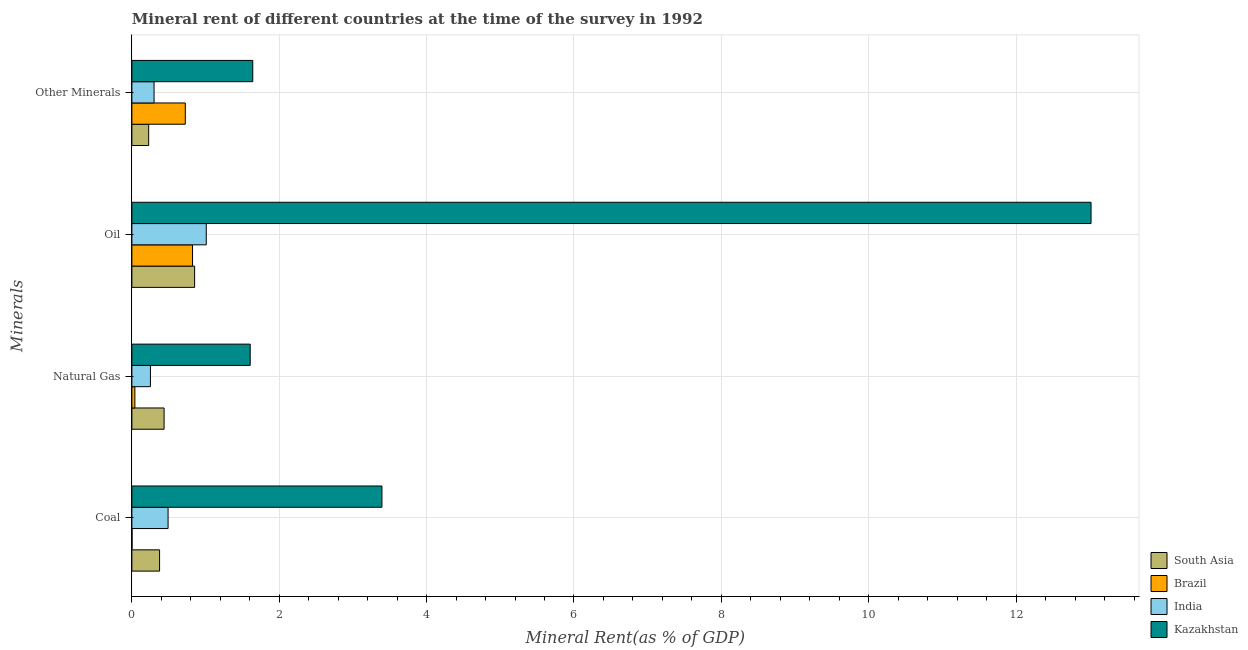How many groups of bars are there?
Provide a succinct answer. 4. Are the number of bars on each tick of the Y-axis equal?
Provide a short and direct response. Yes. How many bars are there on the 1st tick from the top?
Offer a terse response. 4. What is the label of the 1st group of bars from the top?
Ensure brevity in your answer.  Other Minerals. What is the  rent of other minerals in South Asia?
Your answer should be compact. 0.23. Across all countries, what is the maximum coal rent?
Provide a short and direct response. 3.39. Across all countries, what is the minimum coal rent?
Give a very brief answer. 0. In which country was the natural gas rent maximum?
Provide a short and direct response. Kazakhstan. In which country was the  rent of other minerals minimum?
Keep it short and to the point. South Asia. What is the total  rent of other minerals in the graph?
Your answer should be very brief. 2.89. What is the difference between the coal rent in Kazakhstan and that in South Asia?
Your response must be concise. 3.02. What is the difference between the coal rent in Brazil and the oil rent in Kazakhstan?
Your answer should be very brief. -13.01. What is the average oil rent per country?
Ensure brevity in your answer.  3.93. What is the difference between the oil rent and coal rent in Brazil?
Give a very brief answer. 0.82. What is the ratio of the oil rent in South Asia to that in Brazil?
Offer a terse response. 1.03. Is the difference between the natural gas rent in Kazakhstan and India greater than the difference between the  rent of other minerals in Kazakhstan and India?
Ensure brevity in your answer.  Yes. What is the difference between the highest and the second highest  rent of other minerals?
Ensure brevity in your answer.  0.92. What is the difference between the highest and the lowest natural gas rent?
Your response must be concise. 1.57. In how many countries, is the  rent of other minerals greater than the average  rent of other minerals taken over all countries?
Provide a succinct answer. 2. Is it the case that in every country, the sum of the coal rent and natural gas rent is greater than the oil rent?
Your answer should be very brief. No. How many bars are there?
Provide a short and direct response. 16. Are all the bars in the graph horizontal?
Offer a terse response. Yes. How many countries are there in the graph?
Provide a short and direct response. 4. Does the graph contain grids?
Ensure brevity in your answer.  Yes. Where does the legend appear in the graph?
Give a very brief answer. Bottom right. What is the title of the graph?
Your answer should be compact. Mineral rent of different countries at the time of the survey in 1992. What is the label or title of the X-axis?
Your answer should be very brief. Mineral Rent(as % of GDP). What is the label or title of the Y-axis?
Give a very brief answer. Minerals. What is the Mineral Rent(as % of GDP) of South Asia in Coal?
Your answer should be very brief. 0.38. What is the Mineral Rent(as % of GDP) in Brazil in Coal?
Ensure brevity in your answer.  0. What is the Mineral Rent(as % of GDP) in India in Coal?
Your answer should be compact. 0.49. What is the Mineral Rent(as % of GDP) of Kazakhstan in Coal?
Give a very brief answer. 3.39. What is the Mineral Rent(as % of GDP) in South Asia in Natural Gas?
Make the answer very short. 0.44. What is the Mineral Rent(as % of GDP) of Brazil in Natural Gas?
Give a very brief answer. 0.04. What is the Mineral Rent(as % of GDP) in India in Natural Gas?
Offer a terse response. 0.25. What is the Mineral Rent(as % of GDP) in Kazakhstan in Natural Gas?
Offer a very short reply. 1.61. What is the Mineral Rent(as % of GDP) in South Asia in Oil?
Offer a terse response. 0.85. What is the Mineral Rent(as % of GDP) of Brazil in Oil?
Give a very brief answer. 0.82. What is the Mineral Rent(as % of GDP) in India in Oil?
Provide a succinct answer. 1.01. What is the Mineral Rent(as % of GDP) of Kazakhstan in Oil?
Provide a succinct answer. 13.02. What is the Mineral Rent(as % of GDP) of South Asia in Other Minerals?
Your answer should be very brief. 0.23. What is the Mineral Rent(as % of GDP) of Brazil in Other Minerals?
Keep it short and to the point. 0.73. What is the Mineral Rent(as % of GDP) of India in Other Minerals?
Ensure brevity in your answer.  0.3. What is the Mineral Rent(as % of GDP) in Kazakhstan in Other Minerals?
Give a very brief answer. 1.64. Across all Minerals, what is the maximum Mineral Rent(as % of GDP) of South Asia?
Give a very brief answer. 0.85. Across all Minerals, what is the maximum Mineral Rent(as % of GDP) of Brazil?
Your answer should be compact. 0.82. Across all Minerals, what is the maximum Mineral Rent(as % of GDP) in India?
Your answer should be compact. 1.01. Across all Minerals, what is the maximum Mineral Rent(as % of GDP) in Kazakhstan?
Provide a succinct answer. 13.02. Across all Minerals, what is the minimum Mineral Rent(as % of GDP) of South Asia?
Provide a short and direct response. 0.23. Across all Minerals, what is the minimum Mineral Rent(as % of GDP) of Brazil?
Give a very brief answer. 0. Across all Minerals, what is the minimum Mineral Rent(as % of GDP) of India?
Your answer should be very brief. 0.25. Across all Minerals, what is the minimum Mineral Rent(as % of GDP) in Kazakhstan?
Your answer should be very brief. 1.61. What is the total Mineral Rent(as % of GDP) of South Asia in the graph?
Give a very brief answer. 1.89. What is the total Mineral Rent(as % of GDP) of Brazil in the graph?
Ensure brevity in your answer.  1.59. What is the total Mineral Rent(as % of GDP) of India in the graph?
Give a very brief answer. 2.05. What is the total Mineral Rent(as % of GDP) of Kazakhstan in the graph?
Make the answer very short. 19.66. What is the difference between the Mineral Rent(as % of GDP) in South Asia in Coal and that in Natural Gas?
Your response must be concise. -0.06. What is the difference between the Mineral Rent(as % of GDP) of Brazil in Coal and that in Natural Gas?
Make the answer very short. -0.04. What is the difference between the Mineral Rent(as % of GDP) in India in Coal and that in Natural Gas?
Keep it short and to the point. 0.24. What is the difference between the Mineral Rent(as % of GDP) in Kazakhstan in Coal and that in Natural Gas?
Your response must be concise. 1.79. What is the difference between the Mineral Rent(as % of GDP) in South Asia in Coal and that in Oil?
Ensure brevity in your answer.  -0.48. What is the difference between the Mineral Rent(as % of GDP) of Brazil in Coal and that in Oil?
Make the answer very short. -0.82. What is the difference between the Mineral Rent(as % of GDP) in India in Coal and that in Oil?
Your answer should be compact. -0.52. What is the difference between the Mineral Rent(as % of GDP) in Kazakhstan in Coal and that in Oil?
Your answer should be compact. -9.62. What is the difference between the Mineral Rent(as % of GDP) in South Asia in Coal and that in Other Minerals?
Make the answer very short. 0.15. What is the difference between the Mineral Rent(as % of GDP) of Brazil in Coal and that in Other Minerals?
Keep it short and to the point. -0.72. What is the difference between the Mineral Rent(as % of GDP) of India in Coal and that in Other Minerals?
Make the answer very short. 0.19. What is the difference between the Mineral Rent(as % of GDP) in Kazakhstan in Coal and that in Other Minerals?
Offer a terse response. 1.75. What is the difference between the Mineral Rent(as % of GDP) of South Asia in Natural Gas and that in Oil?
Make the answer very short. -0.41. What is the difference between the Mineral Rent(as % of GDP) in Brazil in Natural Gas and that in Oil?
Keep it short and to the point. -0.78. What is the difference between the Mineral Rent(as % of GDP) in India in Natural Gas and that in Oil?
Offer a very short reply. -0.76. What is the difference between the Mineral Rent(as % of GDP) of Kazakhstan in Natural Gas and that in Oil?
Your response must be concise. -11.41. What is the difference between the Mineral Rent(as % of GDP) of South Asia in Natural Gas and that in Other Minerals?
Offer a very short reply. 0.21. What is the difference between the Mineral Rent(as % of GDP) in Brazil in Natural Gas and that in Other Minerals?
Your answer should be very brief. -0.68. What is the difference between the Mineral Rent(as % of GDP) of India in Natural Gas and that in Other Minerals?
Give a very brief answer. -0.05. What is the difference between the Mineral Rent(as % of GDP) of Kazakhstan in Natural Gas and that in Other Minerals?
Keep it short and to the point. -0.03. What is the difference between the Mineral Rent(as % of GDP) of South Asia in Oil and that in Other Minerals?
Keep it short and to the point. 0.62. What is the difference between the Mineral Rent(as % of GDP) in Brazil in Oil and that in Other Minerals?
Offer a very short reply. 0.1. What is the difference between the Mineral Rent(as % of GDP) in India in Oil and that in Other Minerals?
Keep it short and to the point. 0.71. What is the difference between the Mineral Rent(as % of GDP) in Kazakhstan in Oil and that in Other Minerals?
Make the answer very short. 11.38. What is the difference between the Mineral Rent(as % of GDP) of South Asia in Coal and the Mineral Rent(as % of GDP) of Brazil in Natural Gas?
Give a very brief answer. 0.34. What is the difference between the Mineral Rent(as % of GDP) of South Asia in Coal and the Mineral Rent(as % of GDP) of India in Natural Gas?
Your response must be concise. 0.12. What is the difference between the Mineral Rent(as % of GDP) in South Asia in Coal and the Mineral Rent(as % of GDP) in Kazakhstan in Natural Gas?
Ensure brevity in your answer.  -1.23. What is the difference between the Mineral Rent(as % of GDP) in Brazil in Coal and the Mineral Rent(as % of GDP) in India in Natural Gas?
Provide a short and direct response. -0.25. What is the difference between the Mineral Rent(as % of GDP) in Brazil in Coal and the Mineral Rent(as % of GDP) in Kazakhstan in Natural Gas?
Provide a succinct answer. -1.6. What is the difference between the Mineral Rent(as % of GDP) of India in Coal and the Mineral Rent(as % of GDP) of Kazakhstan in Natural Gas?
Give a very brief answer. -1.11. What is the difference between the Mineral Rent(as % of GDP) in South Asia in Coal and the Mineral Rent(as % of GDP) in Brazil in Oil?
Offer a terse response. -0.45. What is the difference between the Mineral Rent(as % of GDP) in South Asia in Coal and the Mineral Rent(as % of GDP) in India in Oil?
Ensure brevity in your answer.  -0.63. What is the difference between the Mineral Rent(as % of GDP) in South Asia in Coal and the Mineral Rent(as % of GDP) in Kazakhstan in Oil?
Your answer should be compact. -12.64. What is the difference between the Mineral Rent(as % of GDP) of Brazil in Coal and the Mineral Rent(as % of GDP) of India in Oil?
Ensure brevity in your answer.  -1.01. What is the difference between the Mineral Rent(as % of GDP) of Brazil in Coal and the Mineral Rent(as % of GDP) of Kazakhstan in Oil?
Make the answer very short. -13.01. What is the difference between the Mineral Rent(as % of GDP) in India in Coal and the Mineral Rent(as % of GDP) in Kazakhstan in Oil?
Offer a very short reply. -12.53. What is the difference between the Mineral Rent(as % of GDP) of South Asia in Coal and the Mineral Rent(as % of GDP) of Brazil in Other Minerals?
Offer a terse response. -0.35. What is the difference between the Mineral Rent(as % of GDP) of South Asia in Coal and the Mineral Rent(as % of GDP) of India in Other Minerals?
Your answer should be very brief. 0.07. What is the difference between the Mineral Rent(as % of GDP) in South Asia in Coal and the Mineral Rent(as % of GDP) in Kazakhstan in Other Minerals?
Your response must be concise. -1.26. What is the difference between the Mineral Rent(as % of GDP) in Brazil in Coal and the Mineral Rent(as % of GDP) in India in Other Minerals?
Offer a very short reply. -0.3. What is the difference between the Mineral Rent(as % of GDP) in Brazil in Coal and the Mineral Rent(as % of GDP) in Kazakhstan in Other Minerals?
Your answer should be compact. -1.64. What is the difference between the Mineral Rent(as % of GDP) in India in Coal and the Mineral Rent(as % of GDP) in Kazakhstan in Other Minerals?
Ensure brevity in your answer.  -1.15. What is the difference between the Mineral Rent(as % of GDP) of South Asia in Natural Gas and the Mineral Rent(as % of GDP) of Brazil in Oil?
Your response must be concise. -0.39. What is the difference between the Mineral Rent(as % of GDP) in South Asia in Natural Gas and the Mineral Rent(as % of GDP) in India in Oil?
Make the answer very short. -0.57. What is the difference between the Mineral Rent(as % of GDP) of South Asia in Natural Gas and the Mineral Rent(as % of GDP) of Kazakhstan in Oil?
Keep it short and to the point. -12.58. What is the difference between the Mineral Rent(as % of GDP) in Brazil in Natural Gas and the Mineral Rent(as % of GDP) in India in Oil?
Ensure brevity in your answer.  -0.97. What is the difference between the Mineral Rent(as % of GDP) of Brazil in Natural Gas and the Mineral Rent(as % of GDP) of Kazakhstan in Oil?
Give a very brief answer. -12.98. What is the difference between the Mineral Rent(as % of GDP) of India in Natural Gas and the Mineral Rent(as % of GDP) of Kazakhstan in Oil?
Make the answer very short. -12.77. What is the difference between the Mineral Rent(as % of GDP) in South Asia in Natural Gas and the Mineral Rent(as % of GDP) in Brazil in Other Minerals?
Give a very brief answer. -0.29. What is the difference between the Mineral Rent(as % of GDP) in South Asia in Natural Gas and the Mineral Rent(as % of GDP) in India in Other Minerals?
Provide a succinct answer. 0.14. What is the difference between the Mineral Rent(as % of GDP) of South Asia in Natural Gas and the Mineral Rent(as % of GDP) of Kazakhstan in Other Minerals?
Provide a succinct answer. -1.2. What is the difference between the Mineral Rent(as % of GDP) of Brazil in Natural Gas and the Mineral Rent(as % of GDP) of India in Other Minerals?
Your response must be concise. -0.26. What is the difference between the Mineral Rent(as % of GDP) in Brazil in Natural Gas and the Mineral Rent(as % of GDP) in Kazakhstan in Other Minerals?
Keep it short and to the point. -1.6. What is the difference between the Mineral Rent(as % of GDP) of India in Natural Gas and the Mineral Rent(as % of GDP) of Kazakhstan in Other Minerals?
Your response must be concise. -1.39. What is the difference between the Mineral Rent(as % of GDP) in South Asia in Oil and the Mineral Rent(as % of GDP) in Brazil in Other Minerals?
Make the answer very short. 0.13. What is the difference between the Mineral Rent(as % of GDP) in South Asia in Oil and the Mineral Rent(as % of GDP) in India in Other Minerals?
Keep it short and to the point. 0.55. What is the difference between the Mineral Rent(as % of GDP) in South Asia in Oil and the Mineral Rent(as % of GDP) in Kazakhstan in Other Minerals?
Ensure brevity in your answer.  -0.79. What is the difference between the Mineral Rent(as % of GDP) in Brazil in Oil and the Mineral Rent(as % of GDP) in India in Other Minerals?
Your answer should be compact. 0.52. What is the difference between the Mineral Rent(as % of GDP) of Brazil in Oil and the Mineral Rent(as % of GDP) of Kazakhstan in Other Minerals?
Ensure brevity in your answer.  -0.82. What is the difference between the Mineral Rent(as % of GDP) in India in Oil and the Mineral Rent(as % of GDP) in Kazakhstan in Other Minerals?
Give a very brief answer. -0.63. What is the average Mineral Rent(as % of GDP) in South Asia per Minerals?
Give a very brief answer. 0.47. What is the average Mineral Rent(as % of GDP) of Brazil per Minerals?
Give a very brief answer. 0.4. What is the average Mineral Rent(as % of GDP) in India per Minerals?
Keep it short and to the point. 0.51. What is the average Mineral Rent(as % of GDP) in Kazakhstan per Minerals?
Provide a succinct answer. 4.91. What is the difference between the Mineral Rent(as % of GDP) of South Asia and Mineral Rent(as % of GDP) of Brazil in Coal?
Your response must be concise. 0.37. What is the difference between the Mineral Rent(as % of GDP) of South Asia and Mineral Rent(as % of GDP) of India in Coal?
Your answer should be very brief. -0.12. What is the difference between the Mineral Rent(as % of GDP) of South Asia and Mineral Rent(as % of GDP) of Kazakhstan in Coal?
Keep it short and to the point. -3.02. What is the difference between the Mineral Rent(as % of GDP) of Brazil and Mineral Rent(as % of GDP) of India in Coal?
Make the answer very short. -0.49. What is the difference between the Mineral Rent(as % of GDP) of Brazil and Mineral Rent(as % of GDP) of Kazakhstan in Coal?
Provide a short and direct response. -3.39. What is the difference between the Mineral Rent(as % of GDP) of India and Mineral Rent(as % of GDP) of Kazakhstan in Coal?
Make the answer very short. -2.9. What is the difference between the Mineral Rent(as % of GDP) in South Asia and Mineral Rent(as % of GDP) in Brazil in Natural Gas?
Provide a short and direct response. 0.4. What is the difference between the Mineral Rent(as % of GDP) in South Asia and Mineral Rent(as % of GDP) in India in Natural Gas?
Ensure brevity in your answer.  0.19. What is the difference between the Mineral Rent(as % of GDP) of South Asia and Mineral Rent(as % of GDP) of Kazakhstan in Natural Gas?
Offer a very short reply. -1.17. What is the difference between the Mineral Rent(as % of GDP) in Brazil and Mineral Rent(as % of GDP) in India in Natural Gas?
Keep it short and to the point. -0.21. What is the difference between the Mineral Rent(as % of GDP) of Brazil and Mineral Rent(as % of GDP) of Kazakhstan in Natural Gas?
Provide a succinct answer. -1.57. What is the difference between the Mineral Rent(as % of GDP) in India and Mineral Rent(as % of GDP) in Kazakhstan in Natural Gas?
Make the answer very short. -1.35. What is the difference between the Mineral Rent(as % of GDP) in South Asia and Mineral Rent(as % of GDP) in Brazil in Oil?
Offer a very short reply. 0.03. What is the difference between the Mineral Rent(as % of GDP) of South Asia and Mineral Rent(as % of GDP) of India in Oil?
Ensure brevity in your answer.  -0.16. What is the difference between the Mineral Rent(as % of GDP) of South Asia and Mineral Rent(as % of GDP) of Kazakhstan in Oil?
Your response must be concise. -12.17. What is the difference between the Mineral Rent(as % of GDP) in Brazil and Mineral Rent(as % of GDP) in India in Oil?
Offer a terse response. -0.19. What is the difference between the Mineral Rent(as % of GDP) of Brazil and Mineral Rent(as % of GDP) of Kazakhstan in Oil?
Provide a succinct answer. -12.19. What is the difference between the Mineral Rent(as % of GDP) of India and Mineral Rent(as % of GDP) of Kazakhstan in Oil?
Offer a very short reply. -12.01. What is the difference between the Mineral Rent(as % of GDP) of South Asia and Mineral Rent(as % of GDP) of Brazil in Other Minerals?
Provide a succinct answer. -0.5. What is the difference between the Mineral Rent(as % of GDP) of South Asia and Mineral Rent(as % of GDP) of India in Other Minerals?
Provide a short and direct response. -0.07. What is the difference between the Mineral Rent(as % of GDP) in South Asia and Mineral Rent(as % of GDP) in Kazakhstan in Other Minerals?
Your answer should be compact. -1.41. What is the difference between the Mineral Rent(as % of GDP) in Brazil and Mineral Rent(as % of GDP) in India in Other Minerals?
Ensure brevity in your answer.  0.42. What is the difference between the Mineral Rent(as % of GDP) in Brazil and Mineral Rent(as % of GDP) in Kazakhstan in Other Minerals?
Keep it short and to the point. -0.92. What is the difference between the Mineral Rent(as % of GDP) in India and Mineral Rent(as % of GDP) in Kazakhstan in Other Minerals?
Provide a succinct answer. -1.34. What is the ratio of the Mineral Rent(as % of GDP) in South Asia in Coal to that in Natural Gas?
Your answer should be very brief. 0.86. What is the ratio of the Mineral Rent(as % of GDP) of Brazil in Coal to that in Natural Gas?
Give a very brief answer. 0.06. What is the ratio of the Mineral Rent(as % of GDP) in India in Coal to that in Natural Gas?
Ensure brevity in your answer.  1.95. What is the ratio of the Mineral Rent(as % of GDP) in Kazakhstan in Coal to that in Natural Gas?
Offer a terse response. 2.11. What is the ratio of the Mineral Rent(as % of GDP) in South Asia in Coal to that in Oil?
Your answer should be very brief. 0.44. What is the ratio of the Mineral Rent(as % of GDP) of Brazil in Coal to that in Oil?
Offer a terse response. 0. What is the ratio of the Mineral Rent(as % of GDP) in India in Coal to that in Oil?
Your answer should be very brief. 0.49. What is the ratio of the Mineral Rent(as % of GDP) in Kazakhstan in Coal to that in Oil?
Keep it short and to the point. 0.26. What is the ratio of the Mineral Rent(as % of GDP) of South Asia in Coal to that in Other Minerals?
Your response must be concise. 1.65. What is the ratio of the Mineral Rent(as % of GDP) of Brazil in Coal to that in Other Minerals?
Provide a succinct answer. 0. What is the ratio of the Mineral Rent(as % of GDP) in India in Coal to that in Other Minerals?
Your response must be concise. 1.63. What is the ratio of the Mineral Rent(as % of GDP) in Kazakhstan in Coal to that in Other Minerals?
Your answer should be very brief. 2.07. What is the ratio of the Mineral Rent(as % of GDP) of South Asia in Natural Gas to that in Oil?
Offer a terse response. 0.51. What is the ratio of the Mineral Rent(as % of GDP) of Brazil in Natural Gas to that in Oil?
Provide a succinct answer. 0.05. What is the ratio of the Mineral Rent(as % of GDP) of India in Natural Gas to that in Oil?
Ensure brevity in your answer.  0.25. What is the ratio of the Mineral Rent(as % of GDP) of Kazakhstan in Natural Gas to that in Oil?
Ensure brevity in your answer.  0.12. What is the ratio of the Mineral Rent(as % of GDP) in South Asia in Natural Gas to that in Other Minerals?
Your response must be concise. 1.92. What is the ratio of the Mineral Rent(as % of GDP) of Brazil in Natural Gas to that in Other Minerals?
Make the answer very short. 0.06. What is the ratio of the Mineral Rent(as % of GDP) in India in Natural Gas to that in Other Minerals?
Provide a succinct answer. 0.84. What is the ratio of the Mineral Rent(as % of GDP) in Kazakhstan in Natural Gas to that in Other Minerals?
Ensure brevity in your answer.  0.98. What is the ratio of the Mineral Rent(as % of GDP) in South Asia in Oil to that in Other Minerals?
Your answer should be very brief. 3.74. What is the ratio of the Mineral Rent(as % of GDP) in Brazil in Oil to that in Other Minerals?
Offer a terse response. 1.14. What is the ratio of the Mineral Rent(as % of GDP) in India in Oil to that in Other Minerals?
Provide a succinct answer. 3.35. What is the ratio of the Mineral Rent(as % of GDP) in Kazakhstan in Oil to that in Other Minerals?
Provide a short and direct response. 7.93. What is the difference between the highest and the second highest Mineral Rent(as % of GDP) in South Asia?
Give a very brief answer. 0.41. What is the difference between the highest and the second highest Mineral Rent(as % of GDP) in Brazil?
Provide a short and direct response. 0.1. What is the difference between the highest and the second highest Mineral Rent(as % of GDP) in India?
Provide a short and direct response. 0.52. What is the difference between the highest and the second highest Mineral Rent(as % of GDP) of Kazakhstan?
Your answer should be very brief. 9.62. What is the difference between the highest and the lowest Mineral Rent(as % of GDP) of South Asia?
Your answer should be very brief. 0.62. What is the difference between the highest and the lowest Mineral Rent(as % of GDP) of Brazil?
Provide a short and direct response. 0.82. What is the difference between the highest and the lowest Mineral Rent(as % of GDP) in India?
Give a very brief answer. 0.76. What is the difference between the highest and the lowest Mineral Rent(as % of GDP) of Kazakhstan?
Make the answer very short. 11.41. 